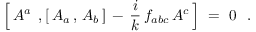Convert formula to latex. <formula><loc_0><loc_0><loc_500><loc_500>\left [ \, A ^ { a } \, , [ \, A _ { a } \, , \, A _ { b } \, ] \, - \, \frac { i } { k } \, f _ { a b c } \, A ^ { c } \, \right ] \ = \ 0 \ \ .</formula> 